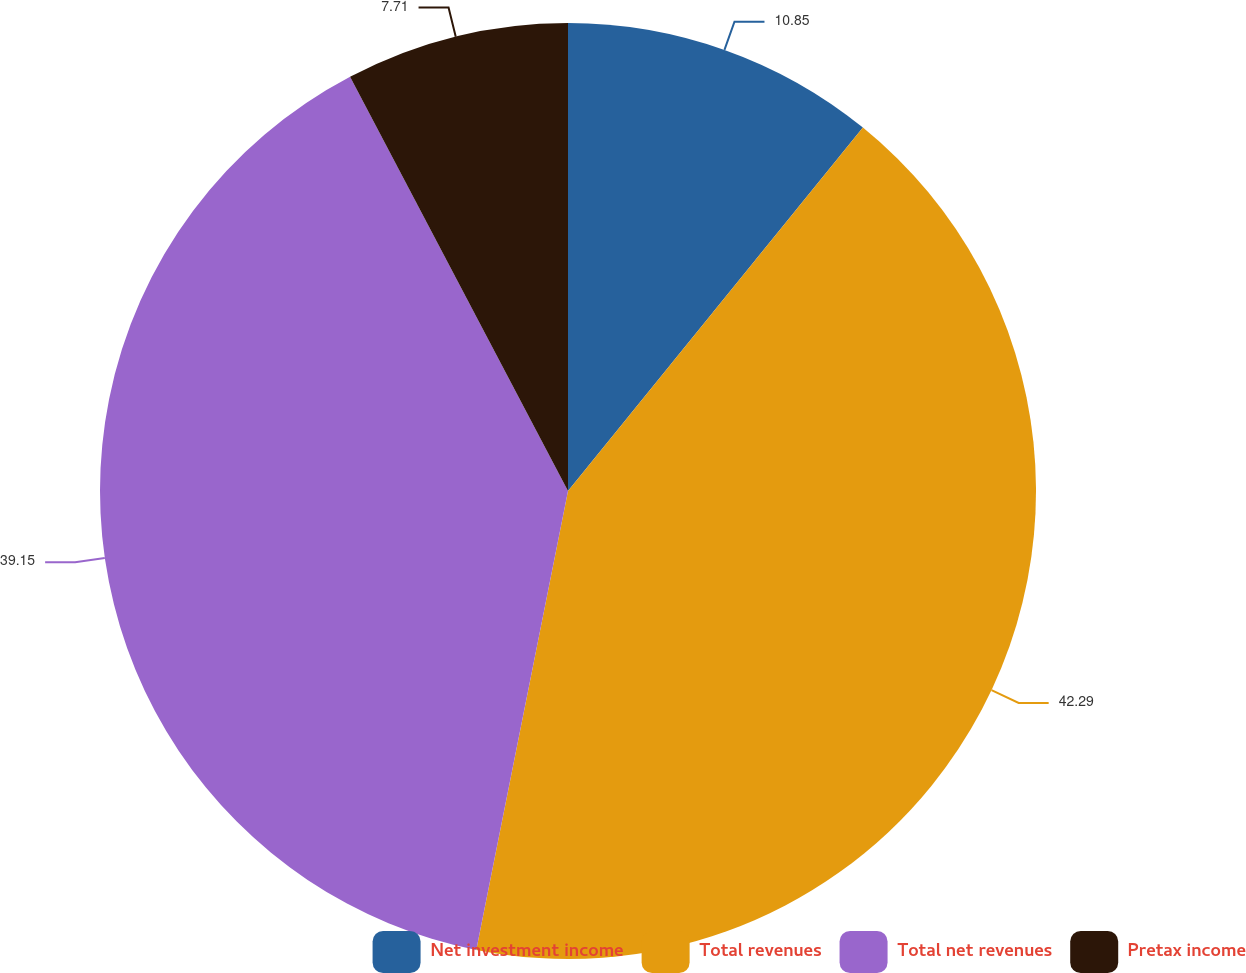Convert chart to OTSL. <chart><loc_0><loc_0><loc_500><loc_500><pie_chart><fcel>Net investment income<fcel>Total revenues<fcel>Total net revenues<fcel>Pretax income<nl><fcel>10.85%<fcel>42.29%<fcel>39.15%<fcel>7.71%<nl></chart> 